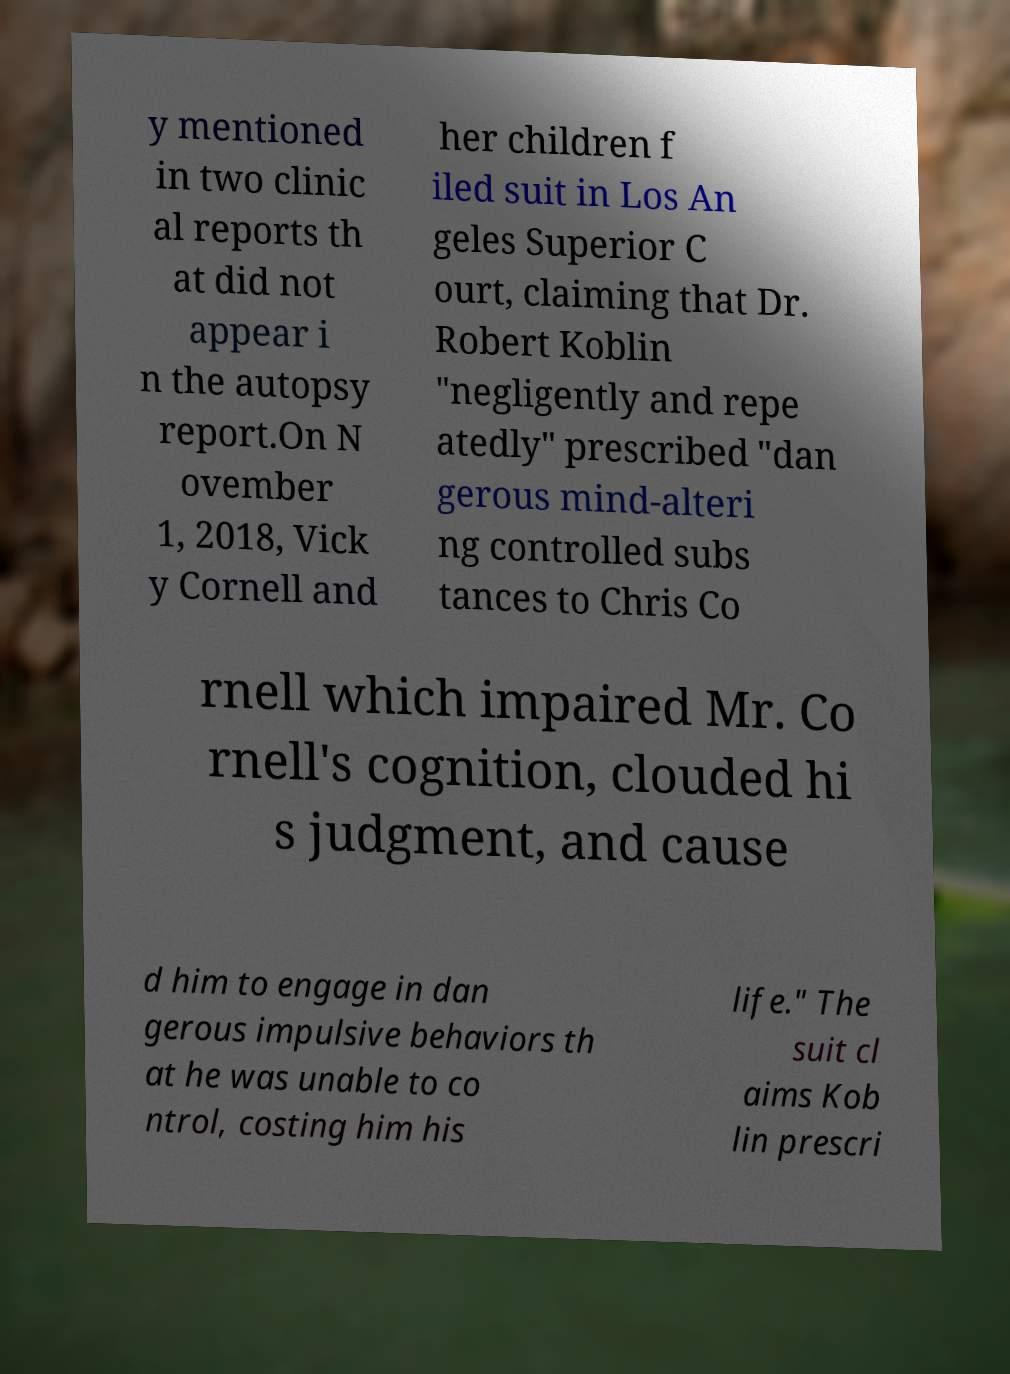I need the written content from this picture converted into text. Can you do that? y mentioned in two clinic al reports th at did not appear i n the autopsy report.On N ovember 1, 2018, Vick y Cornell and her children f iled suit in Los An geles Superior C ourt, claiming that Dr. Robert Koblin "negligently and repe atedly" prescribed "dan gerous mind-alteri ng controlled subs tances to Chris Co rnell which impaired Mr. Co rnell's cognition, clouded hi s judgment, and cause d him to engage in dan gerous impulsive behaviors th at he was unable to co ntrol, costing him his life." The suit cl aims Kob lin prescri 